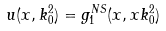<formula> <loc_0><loc_0><loc_500><loc_500>u ( x , k _ { 0 } ^ { 2 } ) = g _ { 1 } ^ { N S } ( x , x k _ { 0 } ^ { 2 } )</formula> 